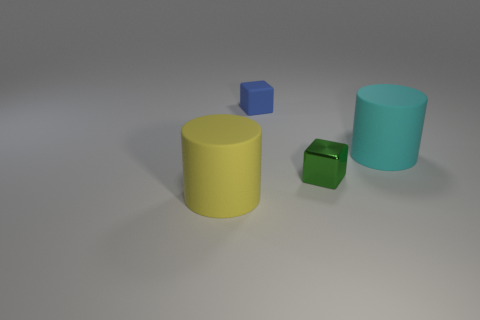Is there a big cyan cylinder that is to the right of the small green thing that is in front of the big cylinder on the right side of the yellow cylinder?
Keep it short and to the point. Yes. Are there more big objects on the right side of the small metallic thing than blue cubes that are behind the tiny blue matte thing?
Offer a very short reply. Yes. What is the material of the green thing that is the same size as the blue thing?
Give a very brief answer. Metal. What number of small things are either rubber cylinders or yellow rubber cylinders?
Your answer should be compact. 0. Does the green thing have the same shape as the blue thing?
Your response must be concise. Yes. What number of rubber objects are both on the left side of the green metal object and behind the large yellow cylinder?
Your response must be concise. 1. The small blue thing that is the same material as the big yellow cylinder is what shape?
Your response must be concise. Cube. Do the yellow thing and the shiny thing have the same size?
Your answer should be compact. No. Do the big object that is right of the tiny blue rubber object and the big yellow object have the same material?
Ensure brevity in your answer.  Yes. Is there anything else that is made of the same material as the small green block?
Your answer should be compact. No. 